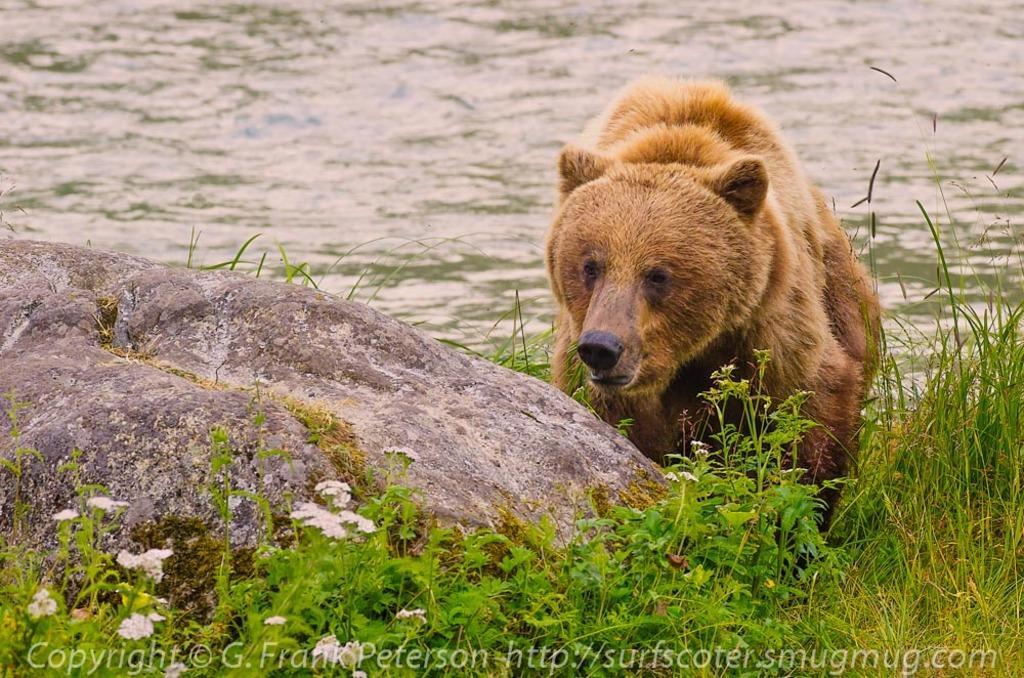Could you give a brief overview of what you see in this image? In this image I can see a bear in brown color. In front I can see few plants in green color, background I can see water. 